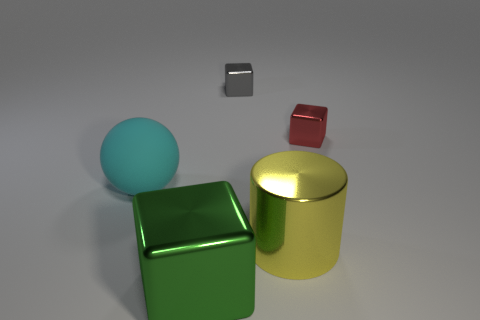Subtract all small blocks. How many blocks are left? 1 Add 2 green blocks. How many objects exist? 7 Subtract all cubes. How many objects are left? 2 Add 5 small gray shiny things. How many small gray shiny things exist? 6 Subtract 0 green spheres. How many objects are left? 5 Subtract all yellow shiny objects. Subtract all green cubes. How many objects are left? 3 Add 4 tiny gray blocks. How many tiny gray blocks are left? 5 